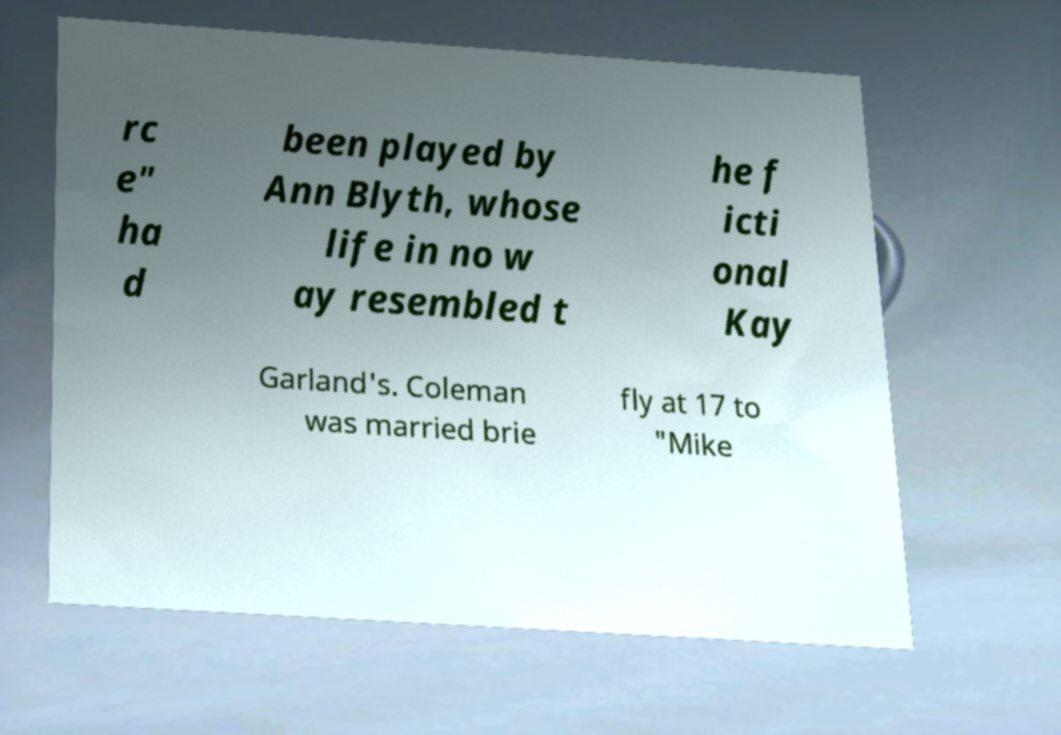Could you assist in decoding the text presented in this image and type it out clearly? rc e" ha d been played by Ann Blyth, whose life in no w ay resembled t he f icti onal Kay Garland's. Coleman was married brie fly at 17 to "Mike 